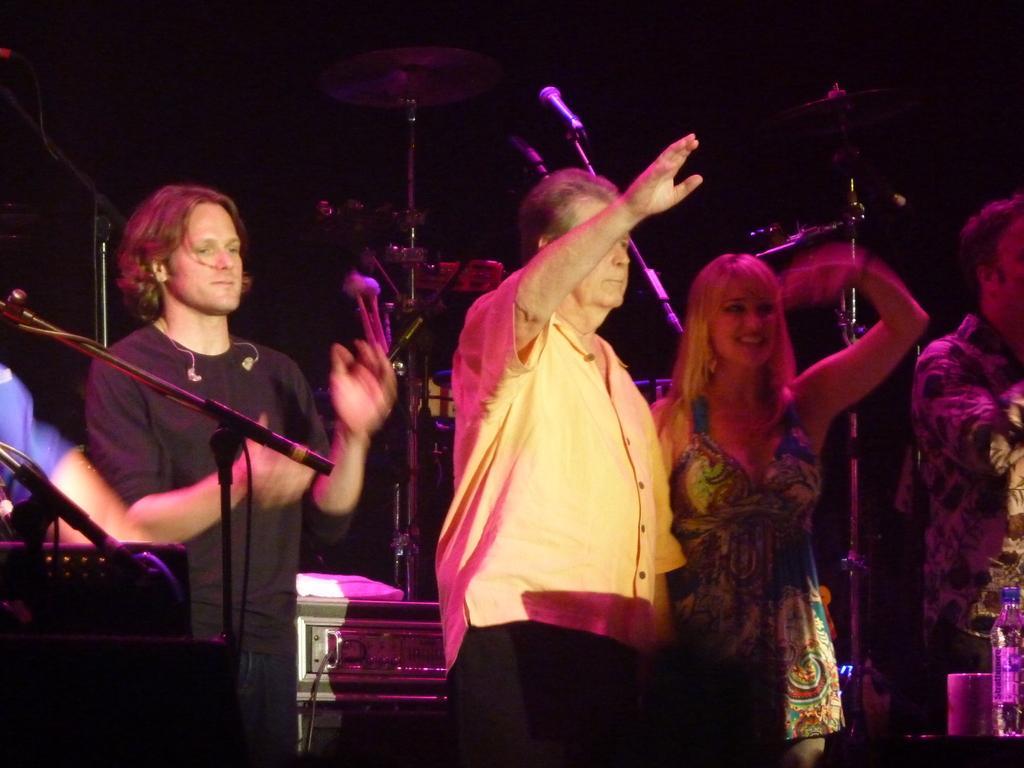Can you describe this image briefly? In this image there are people standing and there are mikes and musical instruments, in the bottom right there is a bottle. 